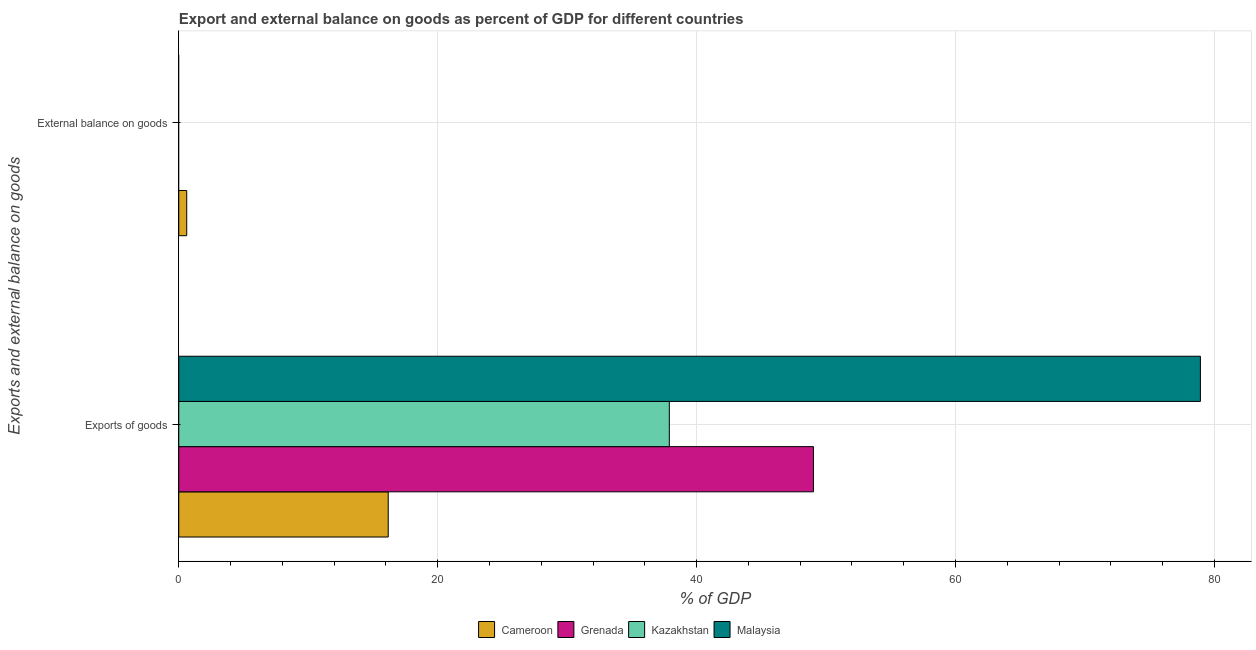Are the number of bars per tick equal to the number of legend labels?
Your answer should be compact. No. Are the number of bars on each tick of the Y-axis equal?
Your answer should be very brief. No. How many bars are there on the 1st tick from the bottom?
Offer a very short reply. 4. What is the label of the 2nd group of bars from the top?
Ensure brevity in your answer.  Exports of goods. What is the external balance on goods as percentage of gdp in Kazakhstan?
Offer a terse response. 0. Across all countries, what is the maximum export of goods as percentage of gdp?
Your answer should be very brief. 78.92. In which country was the external balance on goods as percentage of gdp maximum?
Your answer should be very brief. Cameroon. What is the total export of goods as percentage of gdp in the graph?
Provide a short and direct response. 182.03. What is the difference between the export of goods as percentage of gdp in Malaysia and that in Kazakhstan?
Keep it short and to the point. 41.03. What is the difference between the external balance on goods as percentage of gdp in Grenada and the export of goods as percentage of gdp in Malaysia?
Provide a short and direct response. -78.92. What is the average export of goods as percentage of gdp per country?
Your answer should be compact. 45.51. What is the difference between the export of goods as percentage of gdp and external balance on goods as percentage of gdp in Cameroon?
Provide a short and direct response. 15.57. What is the ratio of the export of goods as percentage of gdp in Malaysia to that in Cameroon?
Offer a terse response. 4.88. How many bars are there?
Your answer should be very brief. 5. Are all the bars in the graph horizontal?
Keep it short and to the point. Yes. How many countries are there in the graph?
Ensure brevity in your answer.  4. Are the values on the major ticks of X-axis written in scientific E-notation?
Provide a short and direct response. No. Does the graph contain grids?
Offer a very short reply. Yes. How many legend labels are there?
Your answer should be very brief. 4. What is the title of the graph?
Your response must be concise. Export and external balance on goods as percent of GDP for different countries. Does "United Arab Emirates" appear as one of the legend labels in the graph?
Provide a short and direct response. No. What is the label or title of the X-axis?
Provide a succinct answer. % of GDP. What is the label or title of the Y-axis?
Ensure brevity in your answer.  Exports and external balance on goods. What is the % of GDP in Cameroon in Exports of goods?
Offer a very short reply. 16.18. What is the % of GDP of Grenada in Exports of goods?
Offer a terse response. 49.03. What is the % of GDP of Kazakhstan in Exports of goods?
Provide a succinct answer. 37.9. What is the % of GDP in Malaysia in Exports of goods?
Give a very brief answer. 78.92. What is the % of GDP of Cameroon in External balance on goods?
Provide a short and direct response. 0.61. What is the % of GDP in Grenada in External balance on goods?
Give a very brief answer. 0. What is the % of GDP of Malaysia in External balance on goods?
Offer a very short reply. 0. Across all Exports and external balance on goods, what is the maximum % of GDP in Cameroon?
Your response must be concise. 16.18. Across all Exports and external balance on goods, what is the maximum % of GDP in Grenada?
Provide a short and direct response. 49.03. Across all Exports and external balance on goods, what is the maximum % of GDP in Kazakhstan?
Make the answer very short. 37.9. Across all Exports and external balance on goods, what is the maximum % of GDP in Malaysia?
Keep it short and to the point. 78.92. Across all Exports and external balance on goods, what is the minimum % of GDP of Cameroon?
Provide a succinct answer. 0.61. Across all Exports and external balance on goods, what is the minimum % of GDP in Kazakhstan?
Provide a succinct answer. 0. Across all Exports and external balance on goods, what is the minimum % of GDP in Malaysia?
Offer a very short reply. 0. What is the total % of GDP of Cameroon in the graph?
Offer a very short reply. 16.79. What is the total % of GDP of Grenada in the graph?
Provide a short and direct response. 49.03. What is the total % of GDP in Kazakhstan in the graph?
Provide a short and direct response. 37.9. What is the total % of GDP of Malaysia in the graph?
Give a very brief answer. 78.92. What is the difference between the % of GDP in Cameroon in Exports of goods and that in External balance on goods?
Ensure brevity in your answer.  15.57. What is the average % of GDP of Cameroon per Exports and external balance on goods?
Provide a succinct answer. 8.4. What is the average % of GDP of Grenada per Exports and external balance on goods?
Ensure brevity in your answer.  24.51. What is the average % of GDP of Kazakhstan per Exports and external balance on goods?
Offer a very short reply. 18.95. What is the average % of GDP of Malaysia per Exports and external balance on goods?
Your answer should be compact. 39.46. What is the difference between the % of GDP of Cameroon and % of GDP of Grenada in Exports of goods?
Ensure brevity in your answer.  -32.85. What is the difference between the % of GDP of Cameroon and % of GDP of Kazakhstan in Exports of goods?
Your response must be concise. -21.72. What is the difference between the % of GDP of Cameroon and % of GDP of Malaysia in Exports of goods?
Offer a terse response. -62.74. What is the difference between the % of GDP in Grenada and % of GDP in Kazakhstan in Exports of goods?
Make the answer very short. 11.13. What is the difference between the % of GDP in Grenada and % of GDP in Malaysia in Exports of goods?
Give a very brief answer. -29.89. What is the difference between the % of GDP of Kazakhstan and % of GDP of Malaysia in Exports of goods?
Make the answer very short. -41.03. What is the ratio of the % of GDP in Cameroon in Exports of goods to that in External balance on goods?
Your answer should be compact. 26.34. What is the difference between the highest and the second highest % of GDP in Cameroon?
Provide a short and direct response. 15.57. What is the difference between the highest and the lowest % of GDP of Cameroon?
Make the answer very short. 15.57. What is the difference between the highest and the lowest % of GDP in Grenada?
Your answer should be very brief. 49.03. What is the difference between the highest and the lowest % of GDP in Kazakhstan?
Ensure brevity in your answer.  37.9. What is the difference between the highest and the lowest % of GDP of Malaysia?
Provide a short and direct response. 78.92. 